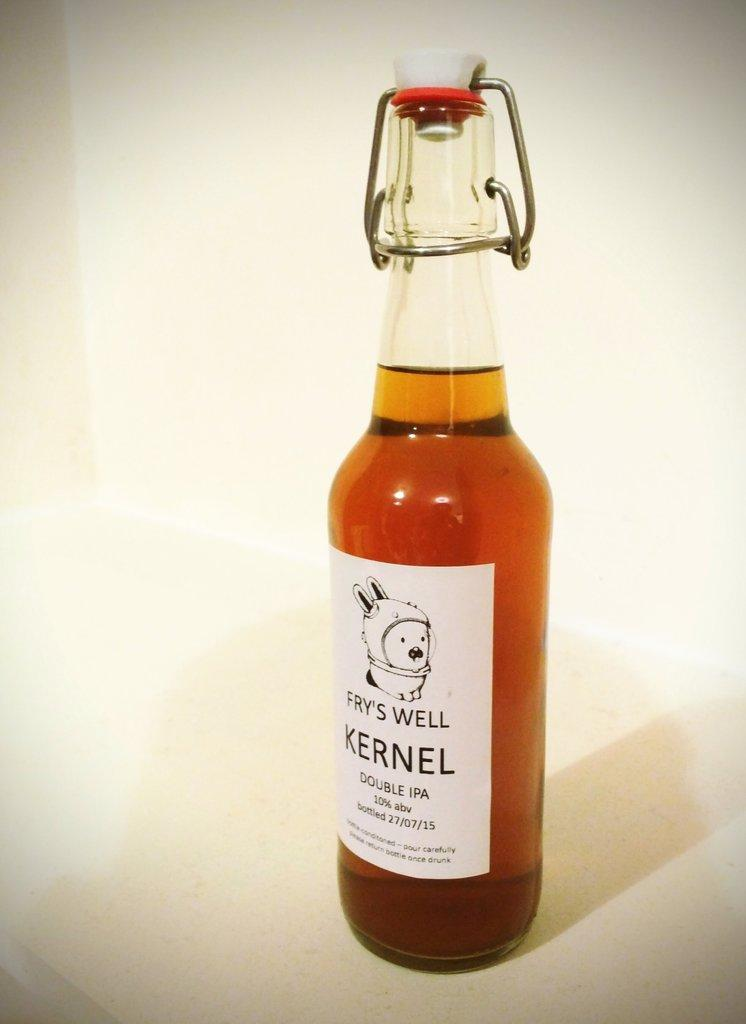<image>
Describe the image concisely. a bottle has the word kernel on it 